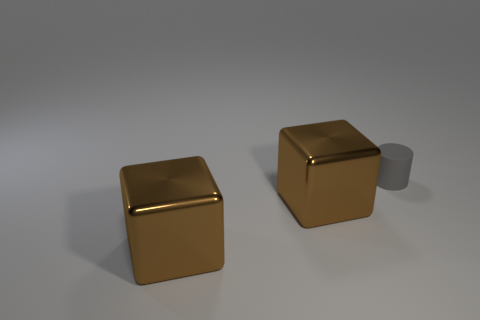Subtract 2 cubes. How many cubes are left? 0 Add 1 small yellow things. How many objects exist? 4 Subtract all purple cylinders. Subtract all yellow blocks. How many cylinders are left? 1 Subtract all cyan cubes. How many brown cylinders are left? 0 Subtract all large brown objects. Subtract all gray things. How many objects are left? 0 Add 3 large brown metallic things. How many large brown metallic things are left? 5 Add 1 big rubber cubes. How many big rubber cubes exist? 1 Subtract 0 purple spheres. How many objects are left? 3 Subtract all cylinders. How many objects are left? 2 